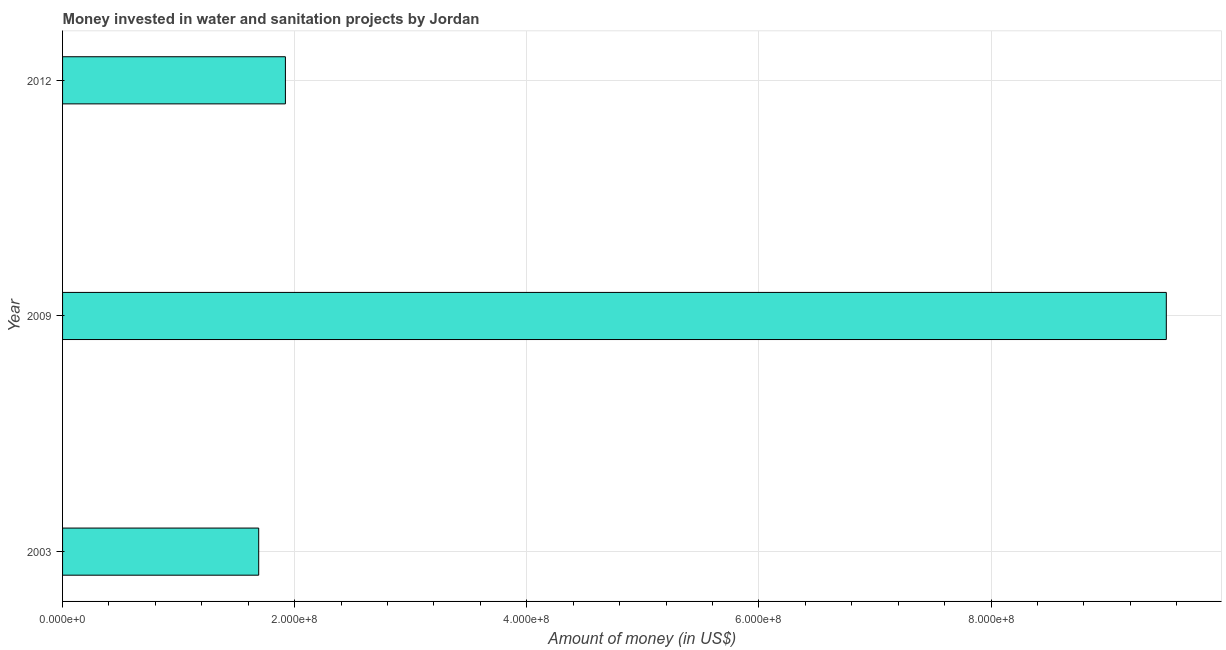Does the graph contain grids?
Give a very brief answer. Yes. What is the title of the graph?
Provide a short and direct response. Money invested in water and sanitation projects by Jordan. What is the label or title of the X-axis?
Make the answer very short. Amount of money (in US$). What is the label or title of the Y-axis?
Provide a succinct answer. Year. What is the investment in 2003?
Provide a succinct answer. 1.69e+08. Across all years, what is the maximum investment?
Offer a very short reply. 9.51e+08. Across all years, what is the minimum investment?
Your answer should be very brief. 1.69e+08. In which year was the investment maximum?
Provide a short and direct response. 2009. In which year was the investment minimum?
Your answer should be compact. 2003. What is the sum of the investment?
Make the answer very short. 1.31e+09. What is the difference between the investment in 2003 and 2009?
Give a very brief answer. -7.82e+08. What is the average investment per year?
Provide a short and direct response. 4.37e+08. What is the median investment?
Provide a succinct answer. 1.92e+08. In how many years, is the investment greater than 480000000 US$?
Offer a very short reply. 1. Do a majority of the years between 2003 and 2012 (inclusive) have investment greater than 400000000 US$?
Your answer should be very brief. No. What is the difference between the highest and the second highest investment?
Ensure brevity in your answer.  7.59e+08. What is the difference between the highest and the lowest investment?
Offer a terse response. 7.82e+08. In how many years, is the investment greater than the average investment taken over all years?
Offer a terse response. 1. What is the Amount of money (in US$) of 2003?
Provide a succinct answer. 1.69e+08. What is the Amount of money (in US$) of 2009?
Your answer should be compact. 9.51e+08. What is the Amount of money (in US$) in 2012?
Your answer should be compact. 1.92e+08. What is the difference between the Amount of money (in US$) in 2003 and 2009?
Your response must be concise. -7.82e+08. What is the difference between the Amount of money (in US$) in 2003 and 2012?
Give a very brief answer. -2.30e+07. What is the difference between the Amount of money (in US$) in 2009 and 2012?
Offer a terse response. 7.59e+08. What is the ratio of the Amount of money (in US$) in 2003 to that in 2009?
Provide a succinct answer. 0.18. What is the ratio of the Amount of money (in US$) in 2009 to that in 2012?
Ensure brevity in your answer.  4.95. 